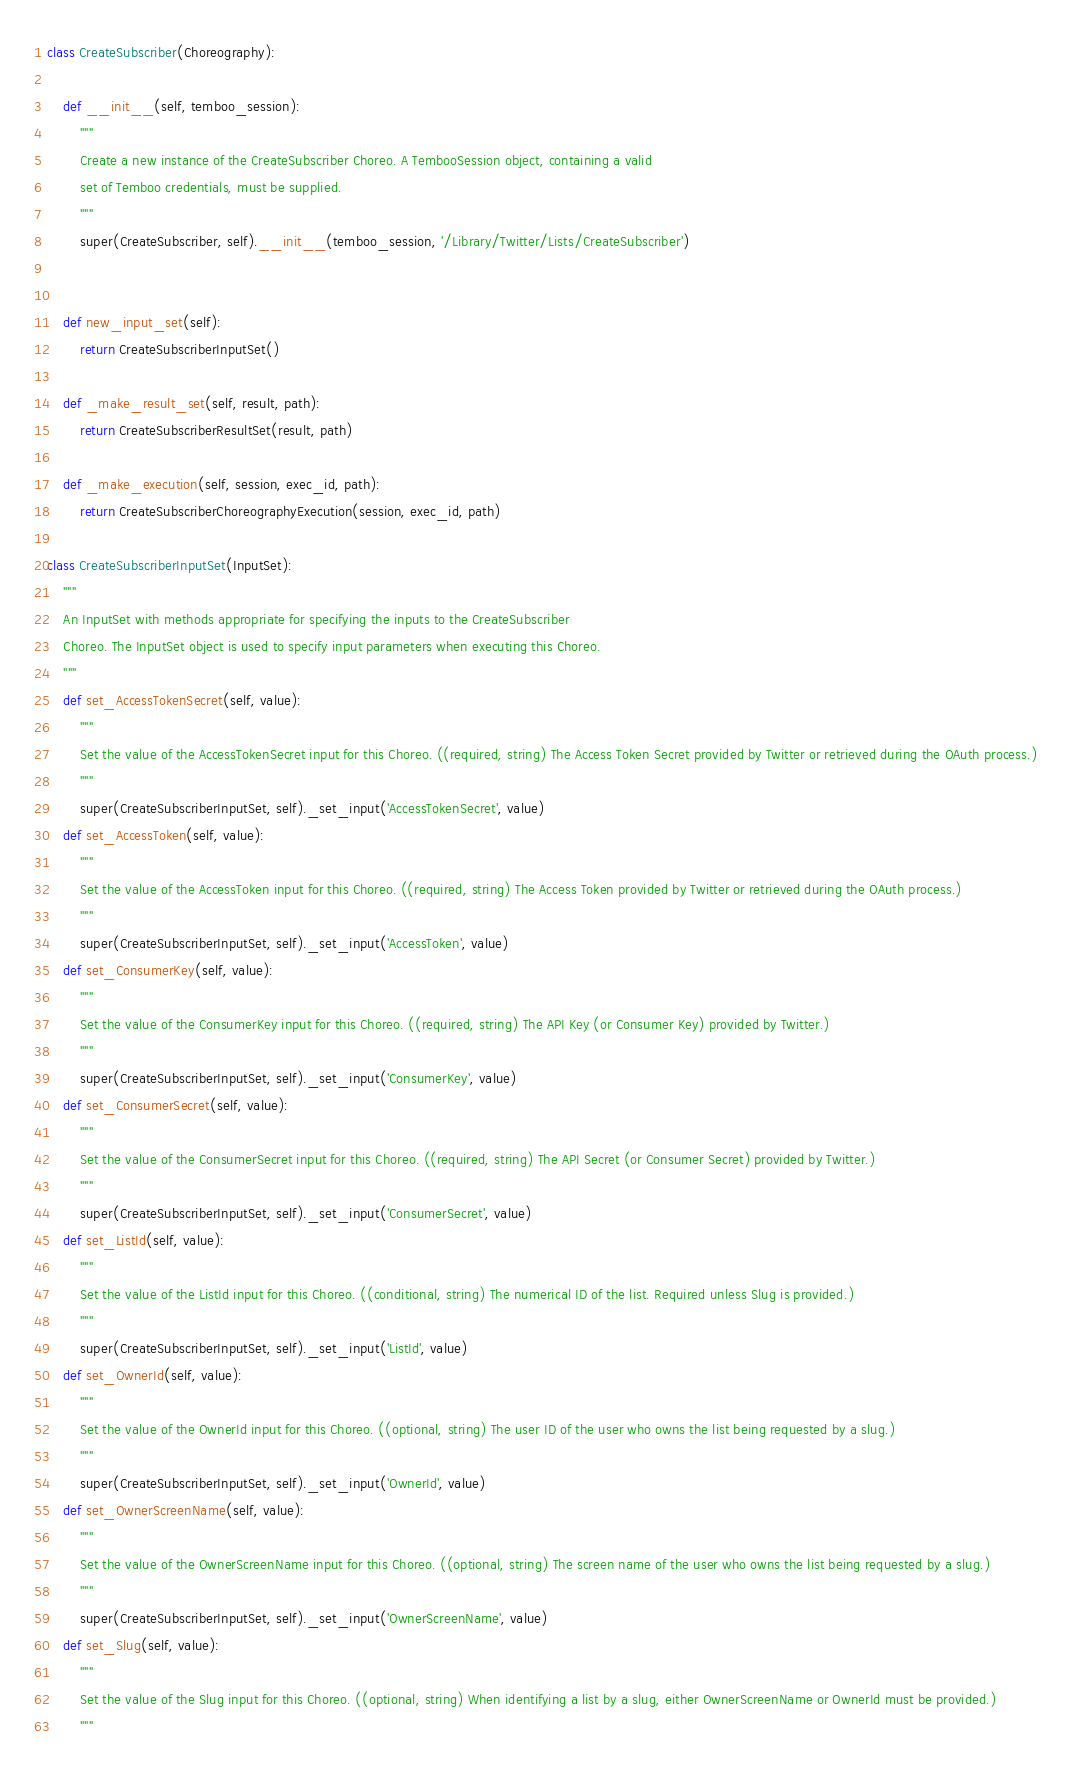Convert code to text. <code><loc_0><loc_0><loc_500><loc_500><_Python_>
class CreateSubscriber(Choreography):

    def __init__(self, temboo_session):
        """
        Create a new instance of the CreateSubscriber Choreo. A TembooSession object, containing a valid
        set of Temboo credentials, must be supplied.
        """
        super(CreateSubscriber, self).__init__(temboo_session, '/Library/Twitter/Lists/CreateSubscriber')


    def new_input_set(self):
        return CreateSubscriberInputSet()

    def _make_result_set(self, result, path):
        return CreateSubscriberResultSet(result, path)

    def _make_execution(self, session, exec_id, path):
        return CreateSubscriberChoreographyExecution(session, exec_id, path)

class CreateSubscriberInputSet(InputSet):
    """
    An InputSet with methods appropriate for specifying the inputs to the CreateSubscriber
    Choreo. The InputSet object is used to specify input parameters when executing this Choreo.
    """
    def set_AccessTokenSecret(self, value):
        """
        Set the value of the AccessTokenSecret input for this Choreo. ((required, string) The Access Token Secret provided by Twitter or retrieved during the OAuth process.)
        """
        super(CreateSubscriberInputSet, self)._set_input('AccessTokenSecret', value)
    def set_AccessToken(self, value):
        """
        Set the value of the AccessToken input for this Choreo. ((required, string) The Access Token provided by Twitter or retrieved during the OAuth process.)
        """
        super(CreateSubscriberInputSet, self)._set_input('AccessToken', value)
    def set_ConsumerKey(self, value):
        """
        Set the value of the ConsumerKey input for this Choreo. ((required, string) The API Key (or Consumer Key) provided by Twitter.)
        """
        super(CreateSubscriberInputSet, self)._set_input('ConsumerKey', value)
    def set_ConsumerSecret(self, value):
        """
        Set the value of the ConsumerSecret input for this Choreo. ((required, string) The API Secret (or Consumer Secret) provided by Twitter.)
        """
        super(CreateSubscriberInputSet, self)._set_input('ConsumerSecret', value)
    def set_ListId(self, value):
        """
        Set the value of the ListId input for this Choreo. ((conditional, string) The numerical ID of the list. Required unless Slug is provided.)
        """
        super(CreateSubscriberInputSet, self)._set_input('ListId', value)
    def set_OwnerId(self, value):
        """
        Set the value of the OwnerId input for this Choreo. ((optional, string) The user ID of the user who owns the list being requested by a slug.)
        """
        super(CreateSubscriberInputSet, self)._set_input('OwnerId', value)
    def set_OwnerScreenName(self, value):
        """
        Set the value of the OwnerScreenName input for this Choreo. ((optional, string) The screen name of the user who owns the list being requested by a slug.)
        """
        super(CreateSubscriberInputSet, self)._set_input('OwnerScreenName', value)
    def set_Slug(self, value):
        """
        Set the value of the Slug input for this Choreo. ((optional, string) When identifying a list by a slug, either OwnerScreenName or OwnerId must be provided.)
        """</code> 